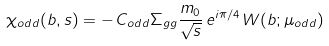Convert formula to latex. <formula><loc_0><loc_0><loc_500><loc_500>\chi _ { o d d } ( b , s ) = - \, C _ { o d d } \Sigma _ { g g } \frac { m _ { 0 } } { \sqrt { s } } \, e ^ { i \pi / 4 } \, W ( b ; \mu _ { o d d } ) \,</formula> 